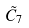<formula> <loc_0><loc_0><loc_500><loc_500>\tilde { C } _ { 7 }</formula> 